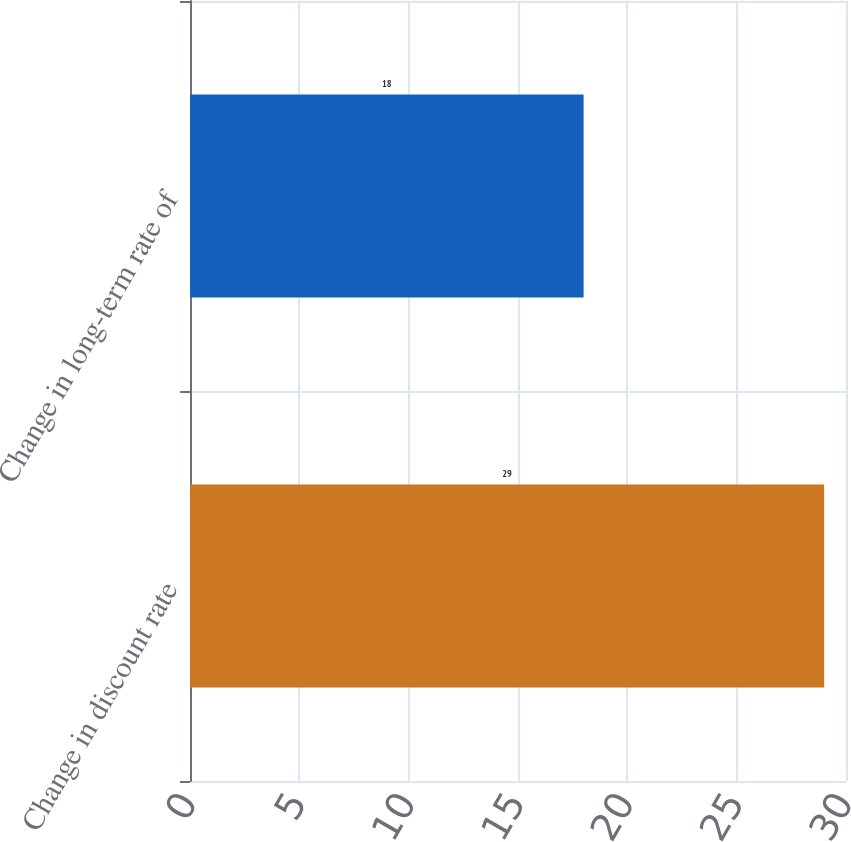Convert chart. <chart><loc_0><loc_0><loc_500><loc_500><bar_chart><fcel>Change in discount rate<fcel>Change in long-term rate of<nl><fcel>29<fcel>18<nl></chart> 